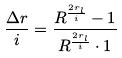<formula> <loc_0><loc_0><loc_500><loc_500>\frac { \Delta r } { i } = \frac { R ^ { \frac { 2 r _ { l } } { i } } - 1 } { R ^ { \frac { 2 r _ { l } } { i } } \cdot 1 }</formula> 